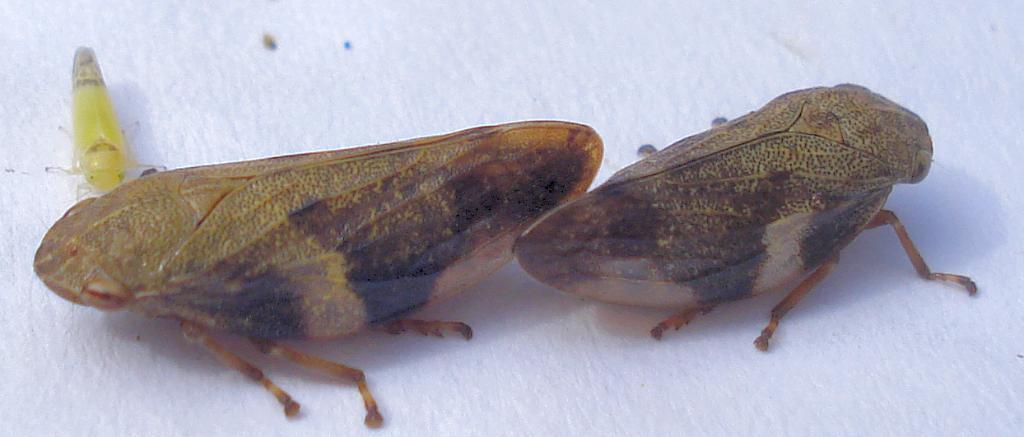What type of creatures can be seen in the image? There are insects in the image. What type of bells can be seen hanging from the insects in the image? There are no bells present in the image; it features insects only. What color is the silver material used by the insects in the image? There is no silver material present in the image; it features insects only. 